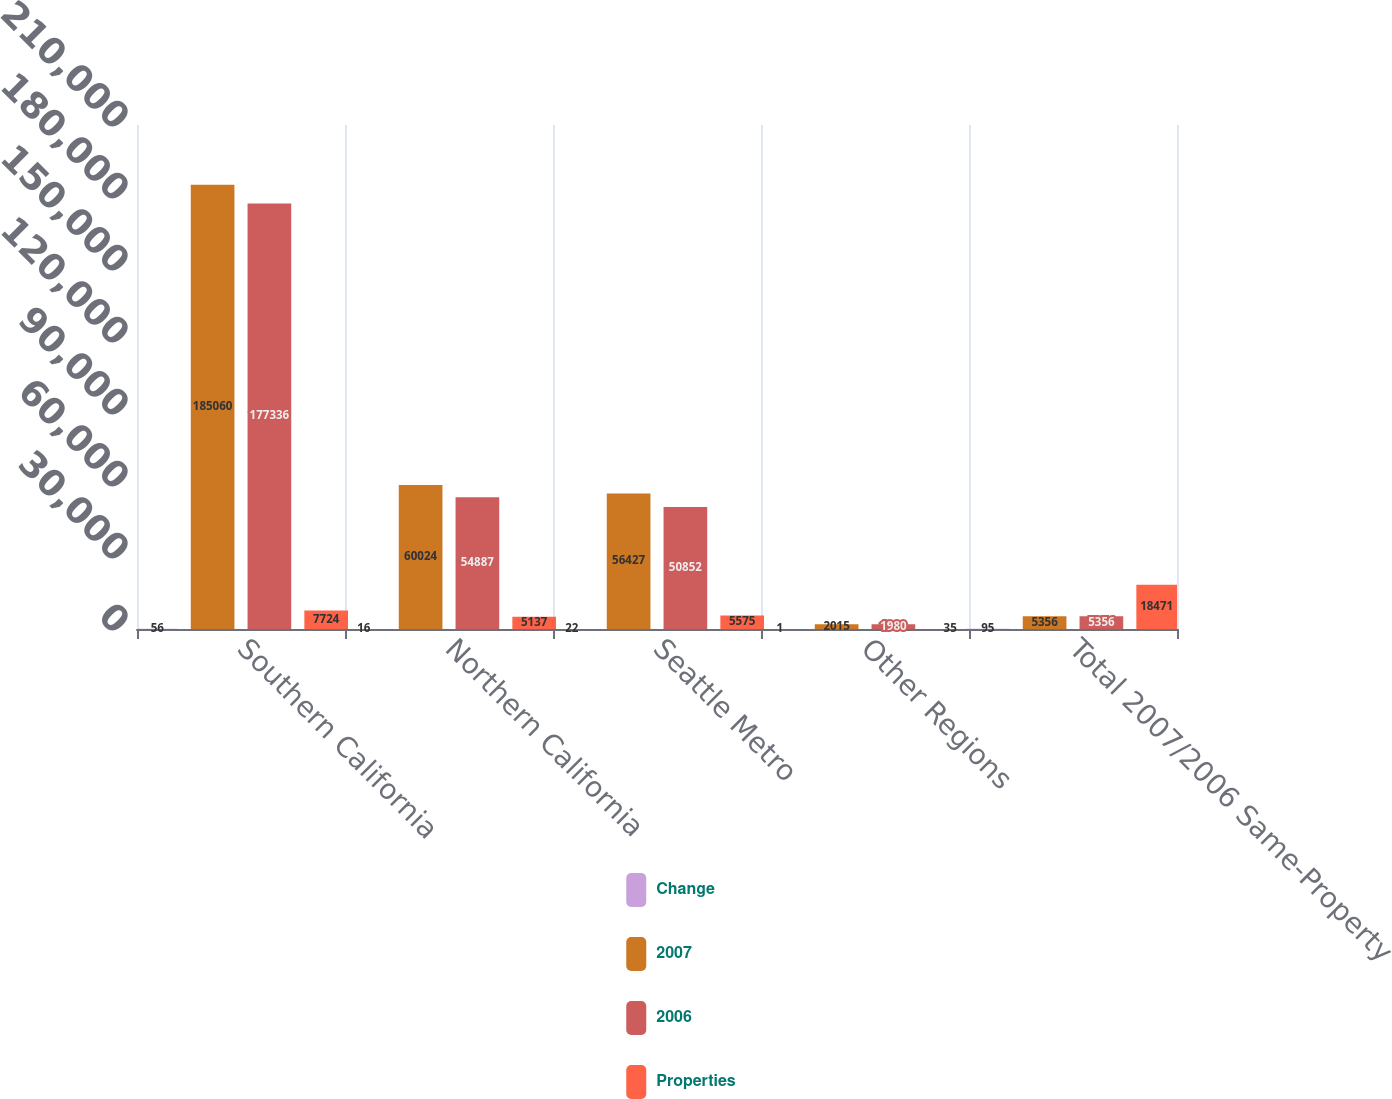Convert chart to OTSL. <chart><loc_0><loc_0><loc_500><loc_500><stacked_bar_chart><ecel><fcel>Southern California<fcel>Northern California<fcel>Seattle Metro<fcel>Other Regions<fcel>Total 2007/2006 Same-Property<nl><fcel>Change<fcel>56<fcel>16<fcel>22<fcel>1<fcel>95<nl><fcel>2007<fcel>185060<fcel>60024<fcel>56427<fcel>2015<fcel>5356<nl><fcel>2006<fcel>177336<fcel>54887<fcel>50852<fcel>1980<fcel>5356<nl><fcel>Properties<fcel>7724<fcel>5137<fcel>5575<fcel>35<fcel>18471<nl></chart> 